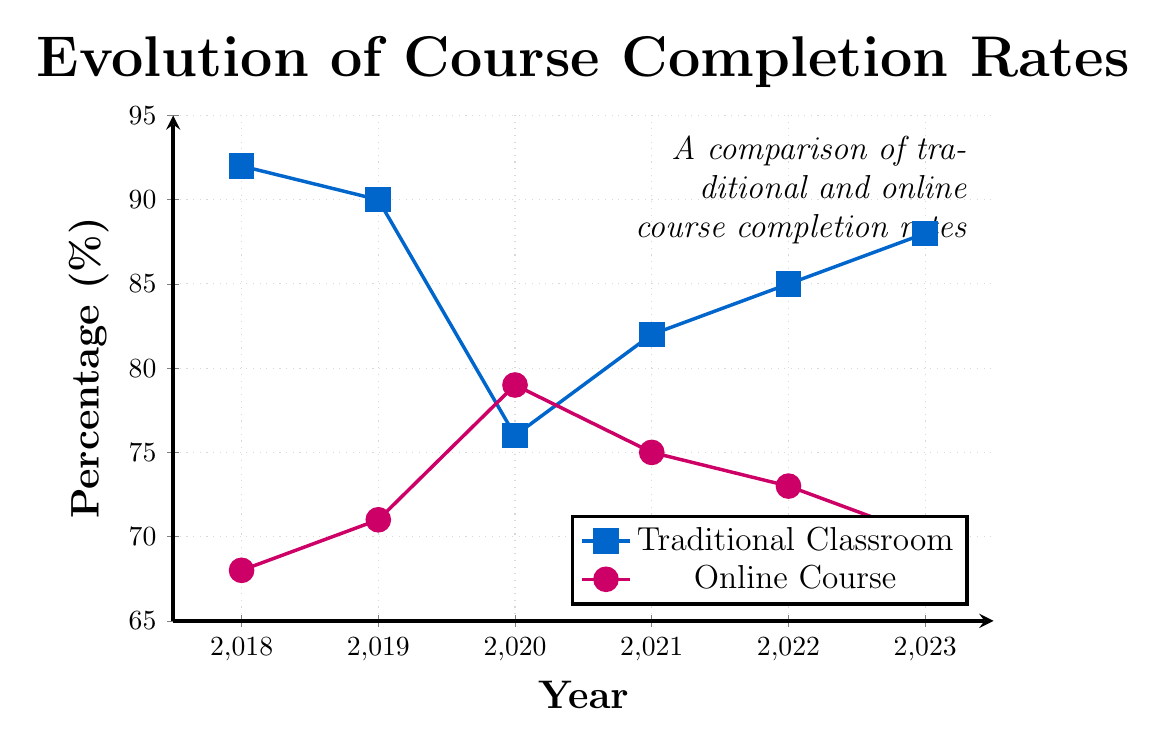What's the percentage difference between Traditional Classroom Attendance and Online Course Completion Rate in 2023? The Traditional Classroom Attendance in 2023 is 88%, and the Online Course Completion Rate is 70%. The difference is calculated as 88 - 70.
Answer: 18 Which year shows the largest gap between Traditional Classroom Attendance and Online Course Completion Rate? By comparing the differences for each year, 2018 has the largest gap, with Traditional at 92% and Online at 68%. The difference is 92 - 68 = 24.
Answer: 2018 What is the general trend observed in Online Course Completion Rate from 2018 to 2023? Observing the data points for Online Course Completion Rates from 2018 to 2023 (68, 71, 79, 75, 73, 70), there's an initial increase until 2020, followed by a declining trend from 2021 onwards.
Answer: Initially increasing, then declining In 2020, how did the Online Course Completion Rate compare to the Traditional Classroom Attendance? In 2020, Online Course Completion Rate is 79% and Traditional Classroom Attendance is 76%. Comparing these values, Online is higher by 79 - 76 = 3.
Answer: Online was higher by 3% Determine the average Traditional Classroom Attendance over the 5 years. Adding the values (92 + 90 + 76 + 82 + 85 + 88) and dividing by the number of years (6), the calculation is (513 / 6 = 85.5).
Answer: 85.5% Which year experienced the highest Online Course Completion Rate, and what was the rate? The highest Online Course Completion Rate is observed in 2020 with a rate of 79%.
Answer: 2020, 79% Compare the overall trend of Traditional Classroom Attendance with that of Online Course Completion Rate. Traditional Attendance shows a decline from 2018 to 2020 followed by a rise until 2023. Online Completion Rate increases to a peak in 2020 and then declines till 2023.
Answer: Traditional dips then rises; Online peaks in 2020 then declines What is the difference between the highest and lowest Traditional Classroom Attendance rates recorded over the years? The highest Traditional Attendance is 92% in 2018, and the lowest is 76% in 2020. The difference is 92 - 76 = 16.
Answer: 16 By how much did the Online Course Completion Rate increase or decrease from 2018 to 2023? The Online Course Completion Rate in 2018 is 68%, and in 2023, it is 70%. The difference is 70 - 68 = 2.
Answer: Increased by 2% 